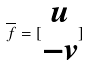Convert formula to latex. <formula><loc_0><loc_0><loc_500><loc_500>\overline { f } = [ \begin{matrix} u \\ - v \end{matrix} ]</formula> 